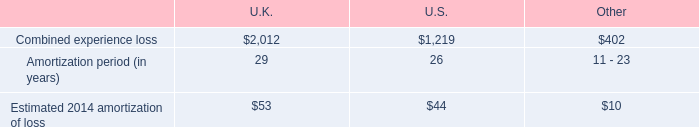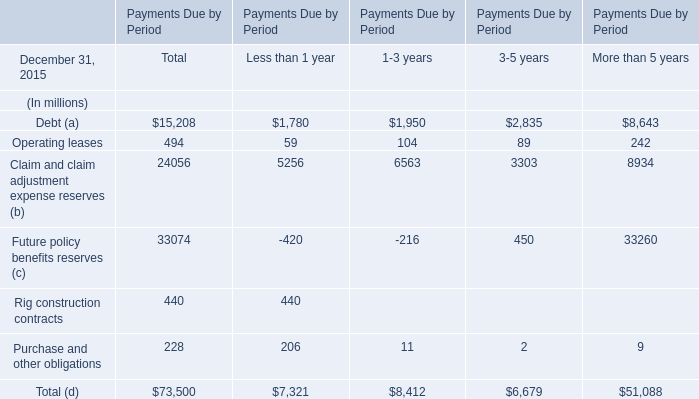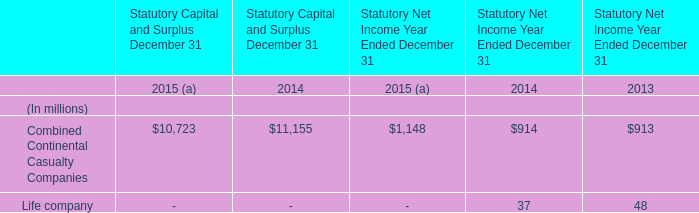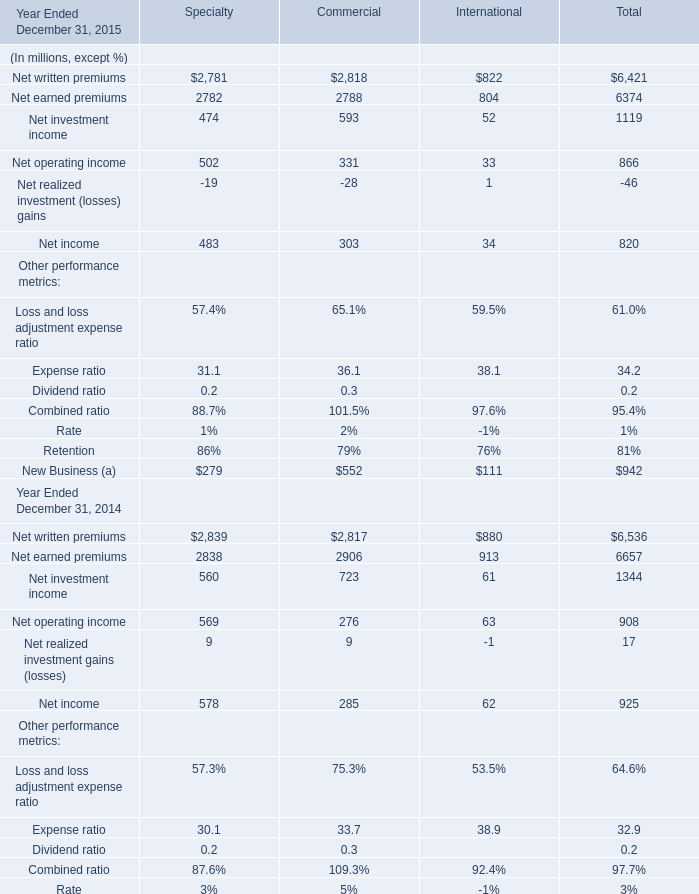In what year is Net operating income for Total greater than 900? 
Answer: 2014. 